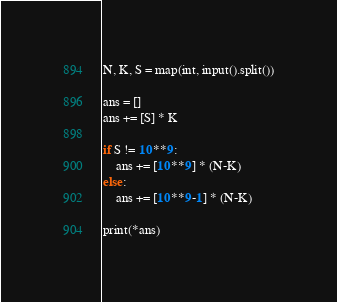Convert code to text. <code><loc_0><loc_0><loc_500><loc_500><_Python_>N, K, S = map(int, input().split())

ans = []
ans += [S] * K

if S != 10**9:
    ans += [10**9] * (N-K)
else:
    ans += [10**9-1] * (N-K)

print(*ans)
</code> 